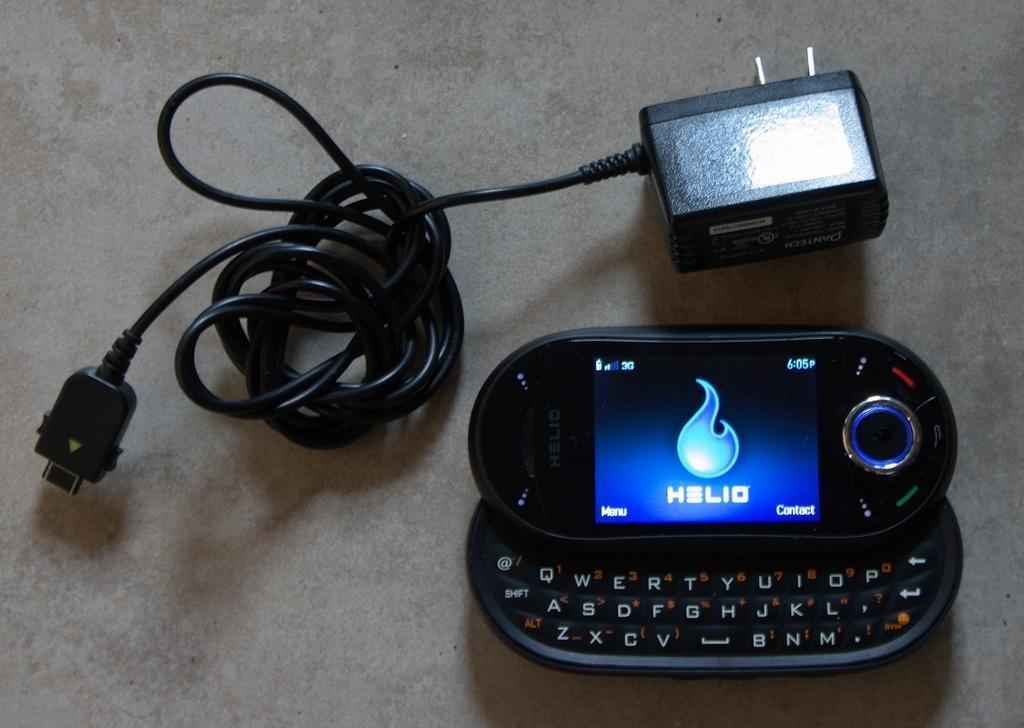Describe this image in one or two sentences. In this image we can see a mobile phone and charger. 